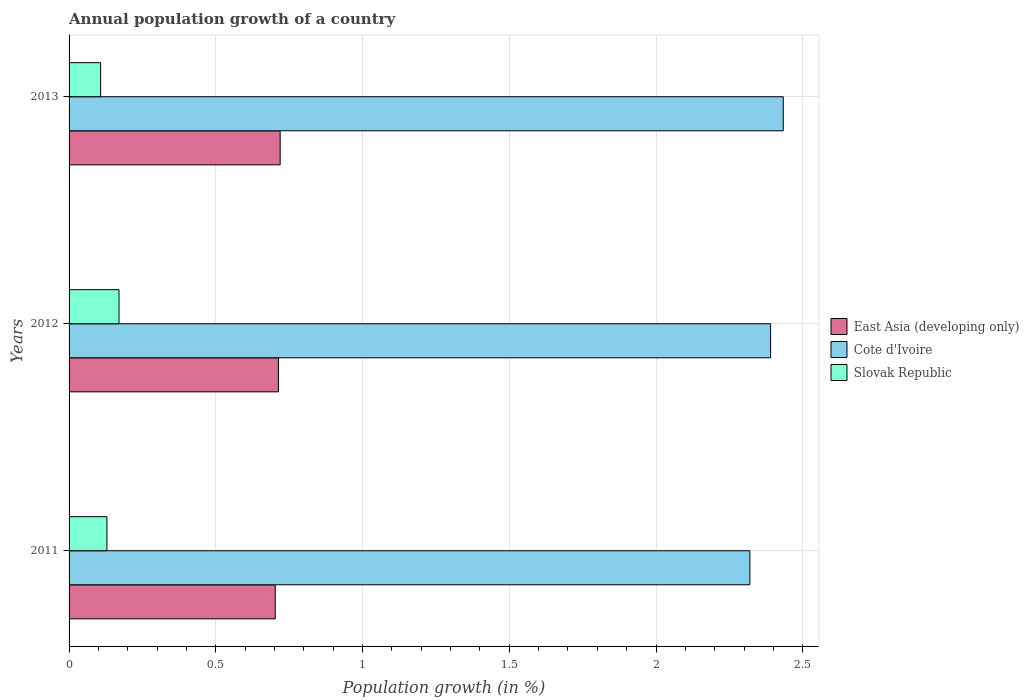How many different coloured bars are there?
Make the answer very short. 3. Are the number of bars per tick equal to the number of legend labels?
Offer a terse response. Yes. How many bars are there on the 2nd tick from the top?
Provide a short and direct response. 3. In how many cases, is the number of bars for a given year not equal to the number of legend labels?
Your answer should be very brief. 0. What is the annual population growth in Slovak Republic in 2011?
Your answer should be compact. 0.13. Across all years, what is the maximum annual population growth in Slovak Republic?
Your answer should be compact. 0.17. Across all years, what is the minimum annual population growth in Slovak Republic?
Offer a terse response. 0.11. What is the total annual population growth in East Asia (developing only) in the graph?
Your response must be concise. 2.14. What is the difference between the annual population growth in Cote d'Ivoire in 2011 and that in 2013?
Offer a very short reply. -0.11. What is the difference between the annual population growth in East Asia (developing only) in 2011 and the annual population growth in Cote d'Ivoire in 2013?
Provide a succinct answer. -1.73. What is the average annual population growth in Slovak Republic per year?
Your answer should be very brief. 0.14. In the year 2013, what is the difference between the annual population growth in East Asia (developing only) and annual population growth in Cote d'Ivoire?
Your answer should be very brief. -1.71. In how many years, is the annual population growth in Cote d'Ivoire greater than 0.5 %?
Make the answer very short. 3. What is the ratio of the annual population growth in Cote d'Ivoire in 2011 to that in 2012?
Your response must be concise. 0.97. Is the annual population growth in East Asia (developing only) in 2012 less than that in 2013?
Make the answer very short. Yes. Is the difference between the annual population growth in East Asia (developing only) in 2011 and 2012 greater than the difference between the annual population growth in Cote d'Ivoire in 2011 and 2012?
Your answer should be compact. Yes. What is the difference between the highest and the second highest annual population growth in Slovak Republic?
Provide a succinct answer. 0.04. What is the difference between the highest and the lowest annual population growth in Cote d'Ivoire?
Give a very brief answer. 0.11. In how many years, is the annual population growth in Slovak Republic greater than the average annual population growth in Slovak Republic taken over all years?
Provide a succinct answer. 1. What does the 2nd bar from the top in 2013 represents?
Keep it short and to the point. Cote d'Ivoire. What does the 2nd bar from the bottom in 2012 represents?
Offer a very short reply. Cote d'Ivoire. How many bars are there?
Offer a very short reply. 9. What is the difference between two consecutive major ticks on the X-axis?
Provide a short and direct response. 0.5. Does the graph contain any zero values?
Your answer should be very brief. No. How many legend labels are there?
Offer a very short reply. 3. How are the legend labels stacked?
Provide a short and direct response. Vertical. What is the title of the graph?
Your response must be concise. Annual population growth of a country. Does "Tajikistan" appear as one of the legend labels in the graph?
Give a very brief answer. No. What is the label or title of the X-axis?
Provide a short and direct response. Population growth (in %). What is the Population growth (in %) in East Asia (developing only) in 2011?
Your answer should be very brief. 0.7. What is the Population growth (in %) of Cote d'Ivoire in 2011?
Make the answer very short. 2.32. What is the Population growth (in %) in Slovak Republic in 2011?
Ensure brevity in your answer.  0.13. What is the Population growth (in %) in East Asia (developing only) in 2012?
Your response must be concise. 0.71. What is the Population growth (in %) of Cote d'Ivoire in 2012?
Offer a terse response. 2.39. What is the Population growth (in %) in Slovak Republic in 2012?
Offer a terse response. 0.17. What is the Population growth (in %) of East Asia (developing only) in 2013?
Your answer should be very brief. 0.72. What is the Population growth (in %) in Cote d'Ivoire in 2013?
Your answer should be compact. 2.43. What is the Population growth (in %) in Slovak Republic in 2013?
Offer a terse response. 0.11. Across all years, what is the maximum Population growth (in %) of East Asia (developing only)?
Keep it short and to the point. 0.72. Across all years, what is the maximum Population growth (in %) of Cote d'Ivoire?
Offer a terse response. 2.43. Across all years, what is the maximum Population growth (in %) in Slovak Republic?
Your response must be concise. 0.17. Across all years, what is the minimum Population growth (in %) of East Asia (developing only)?
Your answer should be compact. 0.7. Across all years, what is the minimum Population growth (in %) in Cote d'Ivoire?
Make the answer very short. 2.32. Across all years, what is the minimum Population growth (in %) of Slovak Republic?
Give a very brief answer. 0.11. What is the total Population growth (in %) in East Asia (developing only) in the graph?
Your response must be concise. 2.14. What is the total Population growth (in %) of Cote d'Ivoire in the graph?
Offer a terse response. 7.14. What is the total Population growth (in %) in Slovak Republic in the graph?
Your answer should be very brief. 0.41. What is the difference between the Population growth (in %) in East Asia (developing only) in 2011 and that in 2012?
Provide a short and direct response. -0.01. What is the difference between the Population growth (in %) in Cote d'Ivoire in 2011 and that in 2012?
Ensure brevity in your answer.  -0.07. What is the difference between the Population growth (in %) in Slovak Republic in 2011 and that in 2012?
Your answer should be compact. -0.04. What is the difference between the Population growth (in %) of East Asia (developing only) in 2011 and that in 2013?
Provide a short and direct response. -0.02. What is the difference between the Population growth (in %) of Cote d'Ivoire in 2011 and that in 2013?
Ensure brevity in your answer.  -0.11. What is the difference between the Population growth (in %) in Slovak Republic in 2011 and that in 2013?
Your response must be concise. 0.02. What is the difference between the Population growth (in %) in East Asia (developing only) in 2012 and that in 2013?
Provide a succinct answer. -0.01. What is the difference between the Population growth (in %) of Cote d'Ivoire in 2012 and that in 2013?
Provide a short and direct response. -0.04. What is the difference between the Population growth (in %) of Slovak Republic in 2012 and that in 2013?
Your answer should be compact. 0.06. What is the difference between the Population growth (in %) in East Asia (developing only) in 2011 and the Population growth (in %) in Cote d'Ivoire in 2012?
Your answer should be compact. -1.69. What is the difference between the Population growth (in %) in East Asia (developing only) in 2011 and the Population growth (in %) in Slovak Republic in 2012?
Make the answer very short. 0.53. What is the difference between the Population growth (in %) in Cote d'Ivoire in 2011 and the Population growth (in %) in Slovak Republic in 2012?
Your answer should be very brief. 2.15. What is the difference between the Population growth (in %) in East Asia (developing only) in 2011 and the Population growth (in %) in Cote d'Ivoire in 2013?
Keep it short and to the point. -1.73. What is the difference between the Population growth (in %) of East Asia (developing only) in 2011 and the Population growth (in %) of Slovak Republic in 2013?
Give a very brief answer. 0.59. What is the difference between the Population growth (in %) of Cote d'Ivoire in 2011 and the Population growth (in %) of Slovak Republic in 2013?
Offer a terse response. 2.21. What is the difference between the Population growth (in %) of East Asia (developing only) in 2012 and the Population growth (in %) of Cote d'Ivoire in 2013?
Give a very brief answer. -1.72. What is the difference between the Population growth (in %) of East Asia (developing only) in 2012 and the Population growth (in %) of Slovak Republic in 2013?
Ensure brevity in your answer.  0.61. What is the difference between the Population growth (in %) in Cote d'Ivoire in 2012 and the Population growth (in %) in Slovak Republic in 2013?
Provide a succinct answer. 2.28. What is the average Population growth (in %) of East Asia (developing only) per year?
Provide a succinct answer. 0.71. What is the average Population growth (in %) in Cote d'Ivoire per year?
Give a very brief answer. 2.38. What is the average Population growth (in %) in Slovak Republic per year?
Keep it short and to the point. 0.14. In the year 2011, what is the difference between the Population growth (in %) of East Asia (developing only) and Population growth (in %) of Cote d'Ivoire?
Your response must be concise. -1.62. In the year 2011, what is the difference between the Population growth (in %) of East Asia (developing only) and Population growth (in %) of Slovak Republic?
Provide a succinct answer. 0.57. In the year 2011, what is the difference between the Population growth (in %) in Cote d'Ivoire and Population growth (in %) in Slovak Republic?
Keep it short and to the point. 2.19. In the year 2012, what is the difference between the Population growth (in %) of East Asia (developing only) and Population growth (in %) of Cote d'Ivoire?
Keep it short and to the point. -1.68. In the year 2012, what is the difference between the Population growth (in %) in East Asia (developing only) and Population growth (in %) in Slovak Republic?
Keep it short and to the point. 0.54. In the year 2012, what is the difference between the Population growth (in %) in Cote d'Ivoire and Population growth (in %) in Slovak Republic?
Provide a short and direct response. 2.22. In the year 2013, what is the difference between the Population growth (in %) in East Asia (developing only) and Population growth (in %) in Cote d'Ivoire?
Offer a terse response. -1.71. In the year 2013, what is the difference between the Population growth (in %) of East Asia (developing only) and Population growth (in %) of Slovak Republic?
Make the answer very short. 0.61. In the year 2013, what is the difference between the Population growth (in %) in Cote d'Ivoire and Population growth (in %) in Slovak Republic?
Keep it short and to the point. 2.33. What is the ratio of the Population growth (in %) of East Asia (developing only) in 2011 to that in 2012?
Your answer should be compact. 0.98. What is the ratio of the Population growth (in %) of Cote d'Ivoire in 2011 to that in 2012?
Keep it short and to the point. 0.97. What is the ratio of the Population growth (in %) in Slovak Republic in 2011 to that in 2012?
Give a very brief answer. 0.76. What is the ratio of the Population growth (in %) in East Asia (developing only) in 2011 to that in 2013?
Your answer should be compact. 0.98. What is the ratio of the Population growth (in %) in Cote d'Ivoire in 2011 to that in 2013?
Keep it short and to the point. 0.95. What is the ratio of the Population growth (in %) in Slovak Republic in 2011 to that in 2013?
Give a very brief answer. 1.2. What is the ratio of the Population growth (in %) in Cote d'Ivoire in 2012 to that in 2013?
Your answer should be very brief. 0.98. What is the ratio of the Population growth (in %) in Slovak Republic in 2012 to that in 2013?
Your response must be concise. 1.58. What is the difference between the highest and the second highest Population growth (in %) of East Asia (developing only)?
Offer a very short reply. 0.01. What is the difference between the highest and the second highest Population growth (in %) in Cote d'Ivoire?
Make the answer very short. 0.04. What is the difference between the highest and the second highest Population growth (in %) in Slovak Republic?
Offer a very short reply. 0.04. What is the difference between the highest and the lowest Population growth (in %) in East Asia (developing only)?
Your answer should be compact. 0.02. What is the difference between the highest and the lowest Population growth (in %) in Cote d'Ivoire?
Make the answer very short. 0.11. What is the difference between the highest and the lowest Population growth (in %) in Slovak Republic?
Give a very brief answer. 0.06. 